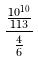<formula> <loc_0><loc_0><loc_500><loc_500>\frac { \frac { 1 0 ^ { 1 0 } } { 1 1 3 } } { \frac { 4 } { 6 } }</formula> 